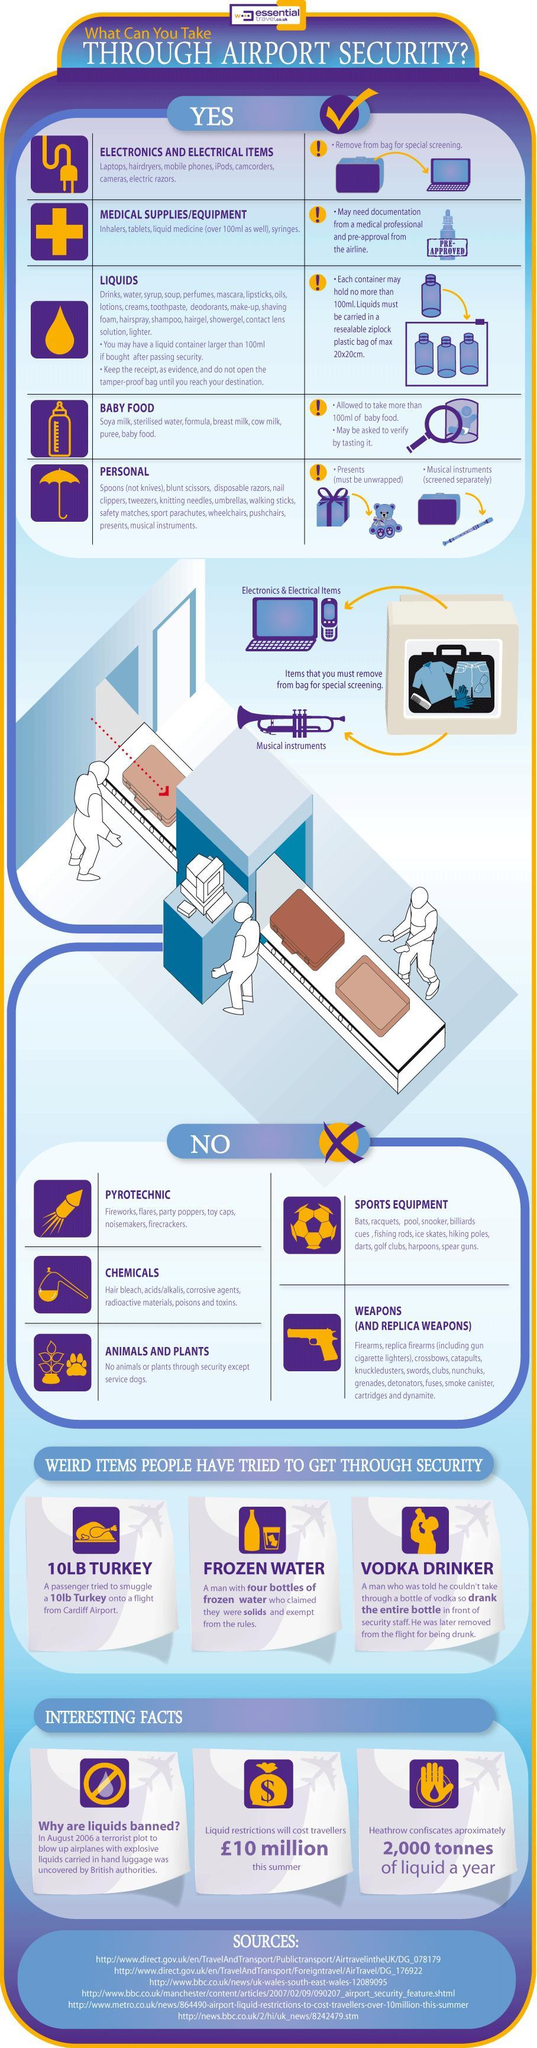How may items can be taken through airport security?
Answer the question with a short phrase. 5 Which item may have to be verified with prescriptions from doctors at the airport security? Medical Supplies / Equipment How many items should be removed from the bag during special screening? 2 